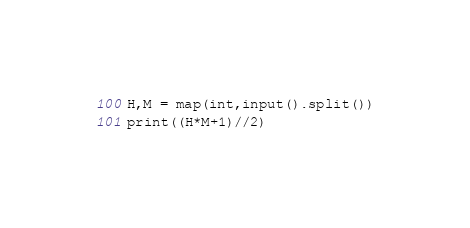Convert code to text. <code><loc_0><loc_0><loc_500><loc_500><_Python_>H,M = map(int,input().split())
print((H*M+1)//2)</code> 